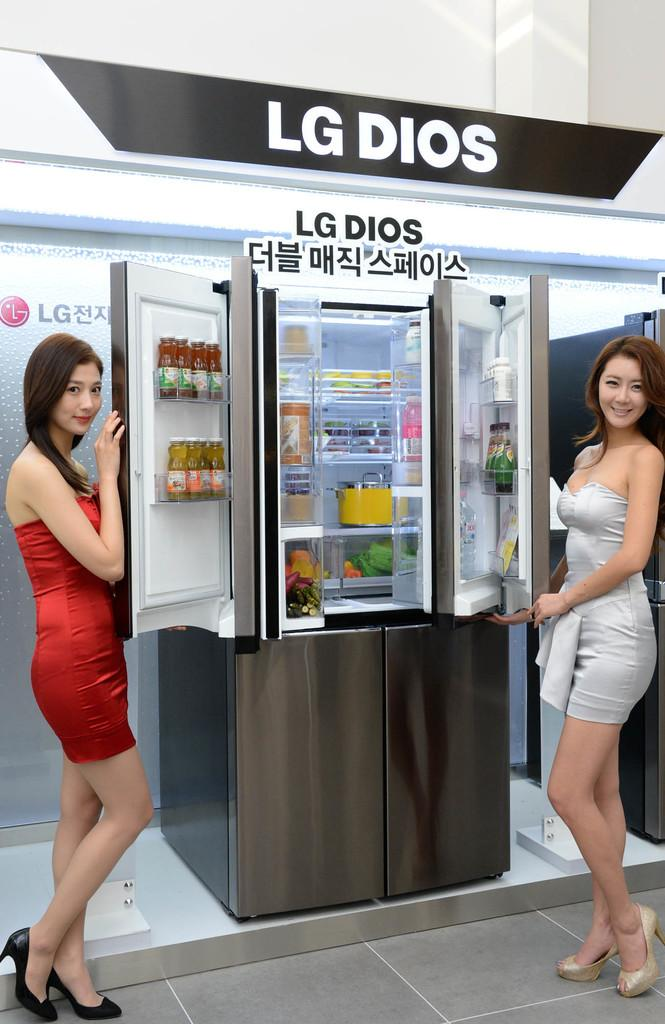Provide a one-sentence caption for the provided image. Two women showcase a stainless steel LG Dios refrigerator. 